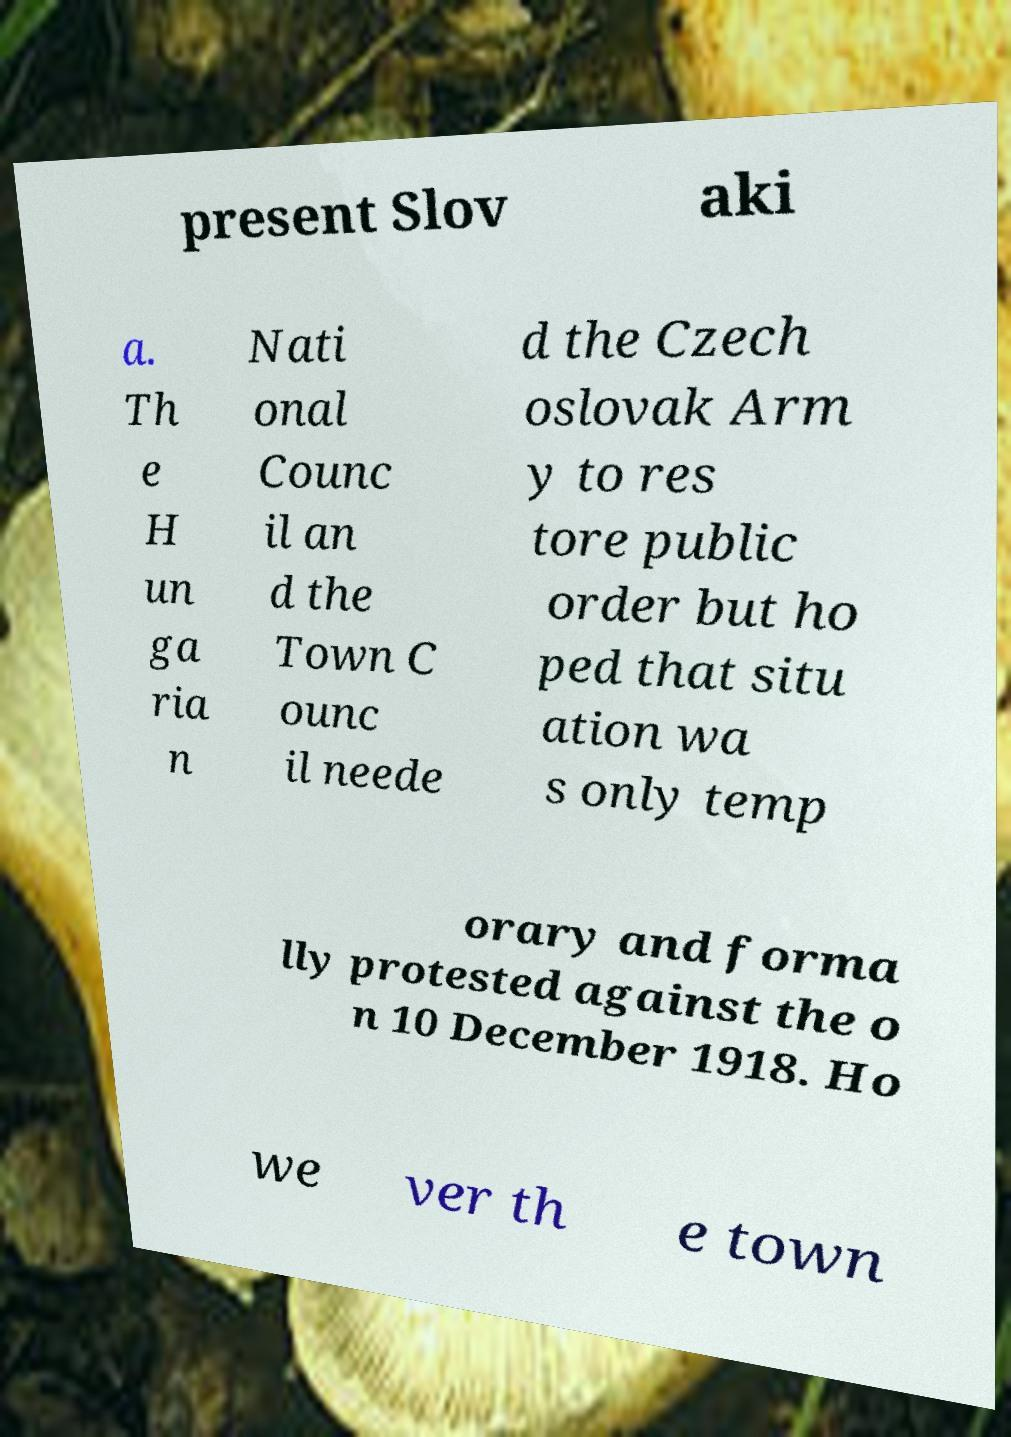Can you read and provide the text displayed in the image?This photo seems to have some interesting text. Can you extract and type it out for me? present Slov aki a. Th e H un ga ria n Nati onal Counc il an d the Town C ounc il neede d the Czech oslovak Arm y to res tore public order but ho ped that situ ation wa s only temp orary and forma lly protested against the o n 10 December 1918. Ho we ver th e town 